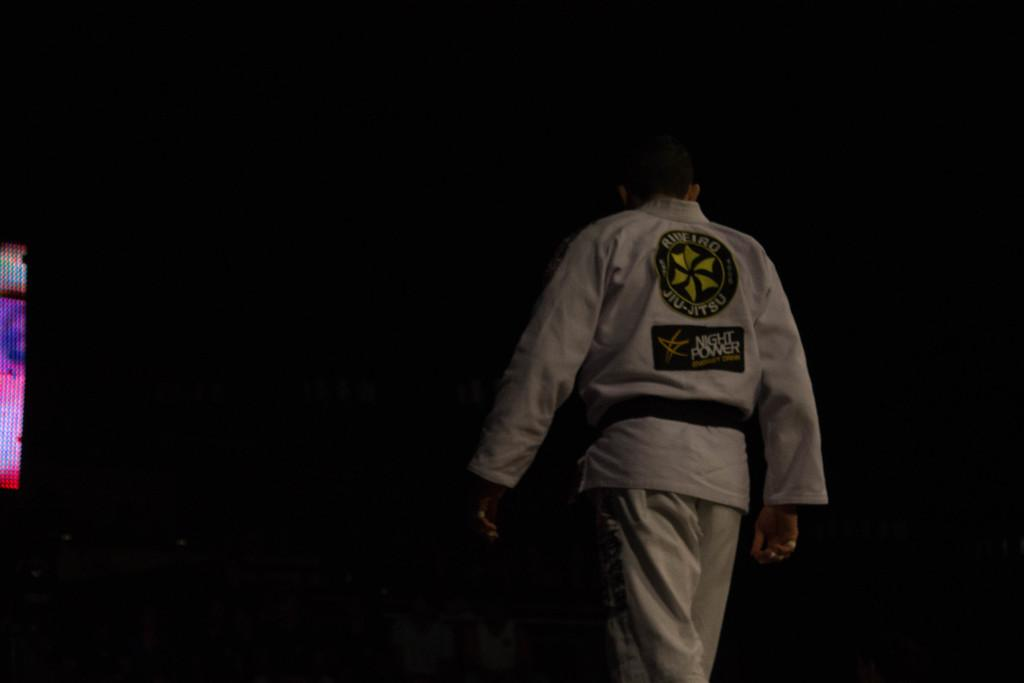<image>
Relay a brief, clear account of the picture shown. a white outfit with the words night power on it 